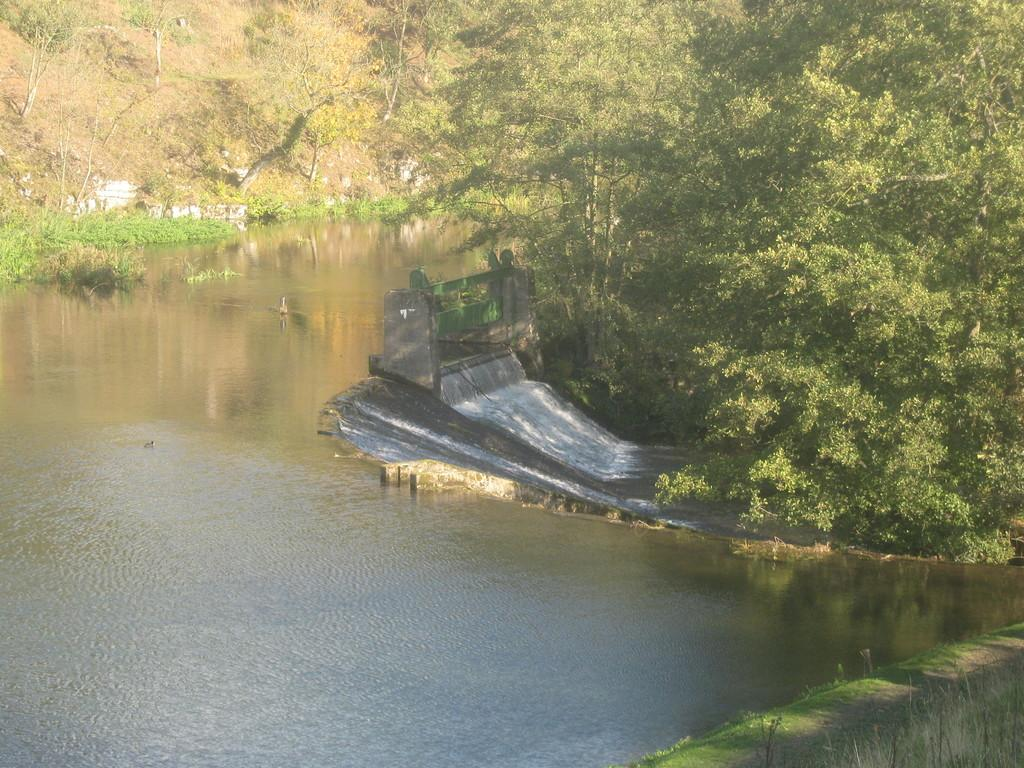What type of natural elements can be seen in the image? There are trees and hills visible in the image. What type of structure is present in the background of the image? There is a house in the background of the image. What is visible in the front of the image? There is water visible in the front of the image. What type of magic is being performed with the curtain and egg in the image? There is no magic, curtain, or egg present in the image. 